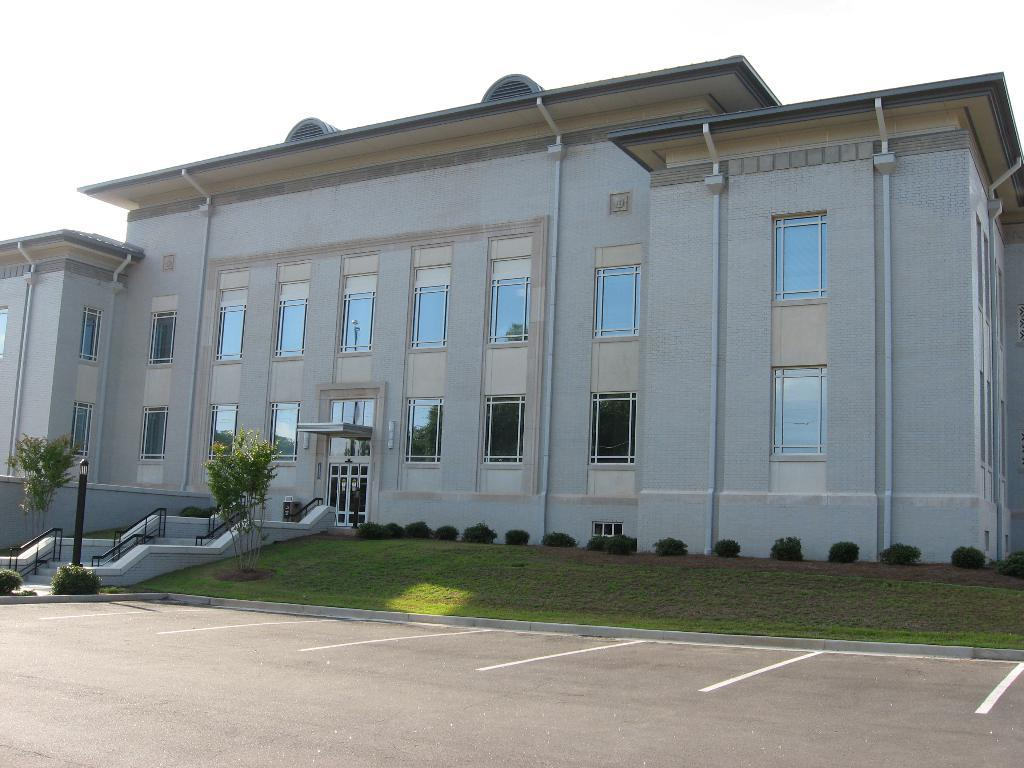What type of surface is present in the center of the image? There is grass on the ground in the center of the image. What can be seen in the distance behind the grass? There is a building in the background of the image. What is located in front of the building? There are plants and a pole in front of the building. How can one access the building from the grassy area? There are stairs in front of the building. What type of glass is used to create the form of the yarn in the image? There is no glass or yarn present in the image; it features grass, a building, plants, a pole, and stairs. 